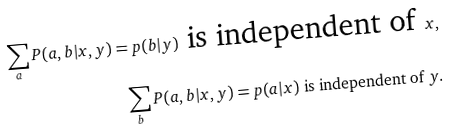Convert formula to latex. <formula><loc_0><loc_0><loc_500><loc_500>\sum _ { a } P ( a , b | x , y ) = p ( b | y ) \text { is independent of } x , \\ \sum _ { b } P ( a , b | x , y ) = p ( a | x ) \text { is independent of } y .</formula> 